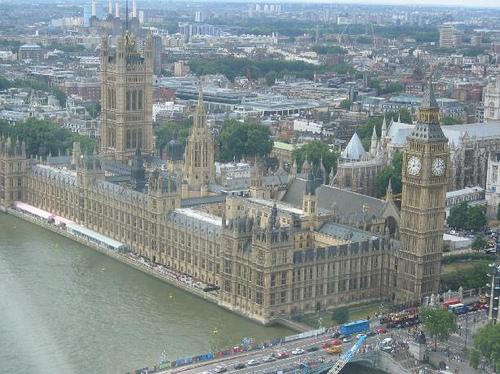Is the landmark shown in this image internationally famous?
Short answer required. Yes. Can you see a blue bus?
Answer briefly. Yes. What time is it?
Quick response, please. 12:15. 